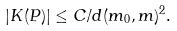Convert formula to latex. <formula><loc_0><loc_0><loc_500><loc_500>| K ( P ) | \leq C / d ( m _ { 0 } , m ) ^ { 2 } .</formula> 